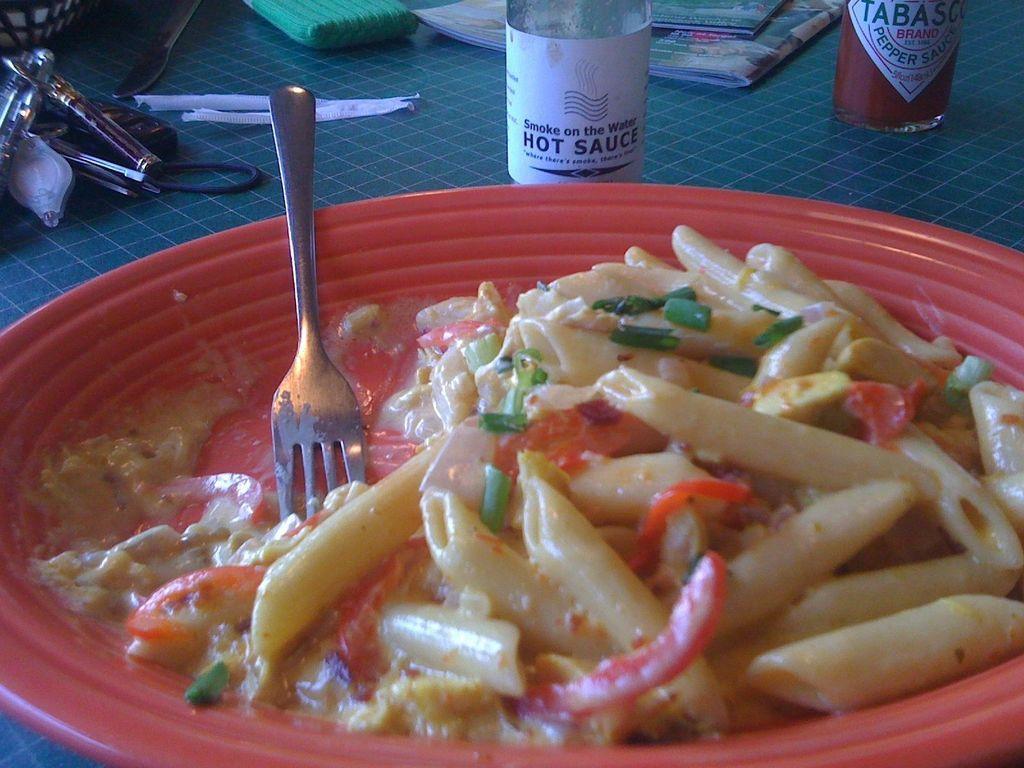Describe this image in one or two sentences. In this picture we can see a plate of white sauce pasta with a fork. In the background, we can see hot sauce and many other things. 